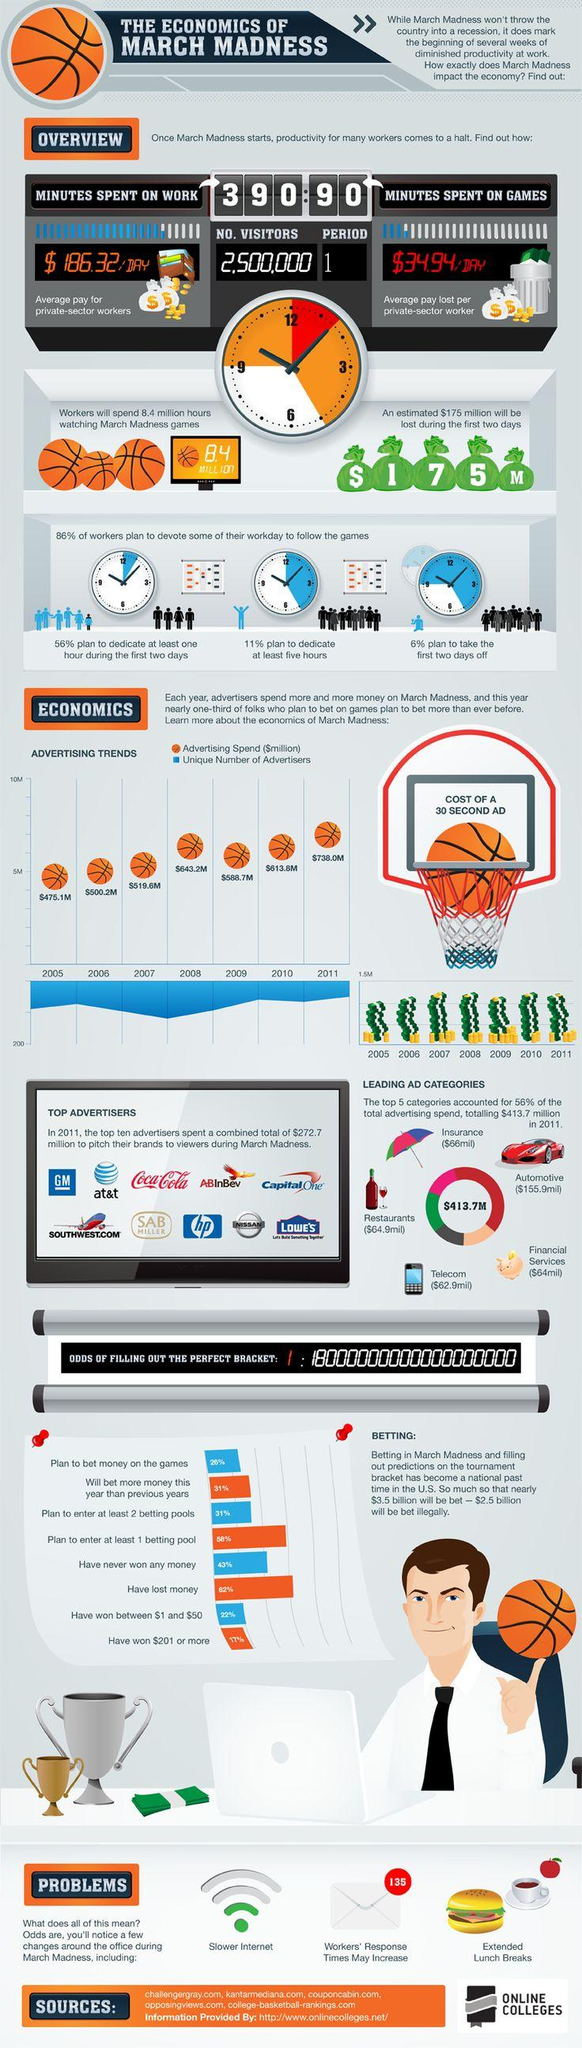List a handful of essential elements in this visual. In 2006, the advertising spend was the second lowest. The loss of revenue on the first two days of the game is expected to be $175 million. Among the top ten advertisers, several brewing or beverage companies were prominent, including Coca-Cola, ABInBev, and SAB Miller. March Madness is a time of frenzied excitement and intense competition, as basketball teams from across the country vie for the top spot in the NCAA Men's Division I Basketball Championship. Football and basketball share many similarities, but it is the game of basketball that captures the hearts and minds of fans during this time of year. The amount of time spent on games is approximately 1.5 hours. 